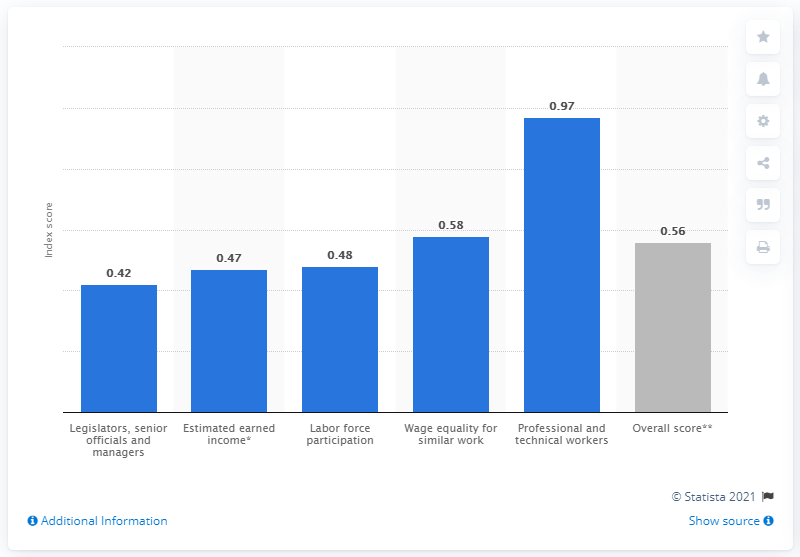List a handful of essential elements in this visual. According to the 2021 Global Gender Gap Report, Guatemala's gender gap index score was 0.56, indicating that the country has a moderate level of gender inequality in areas such as health, education, economic participation, and political representation. 